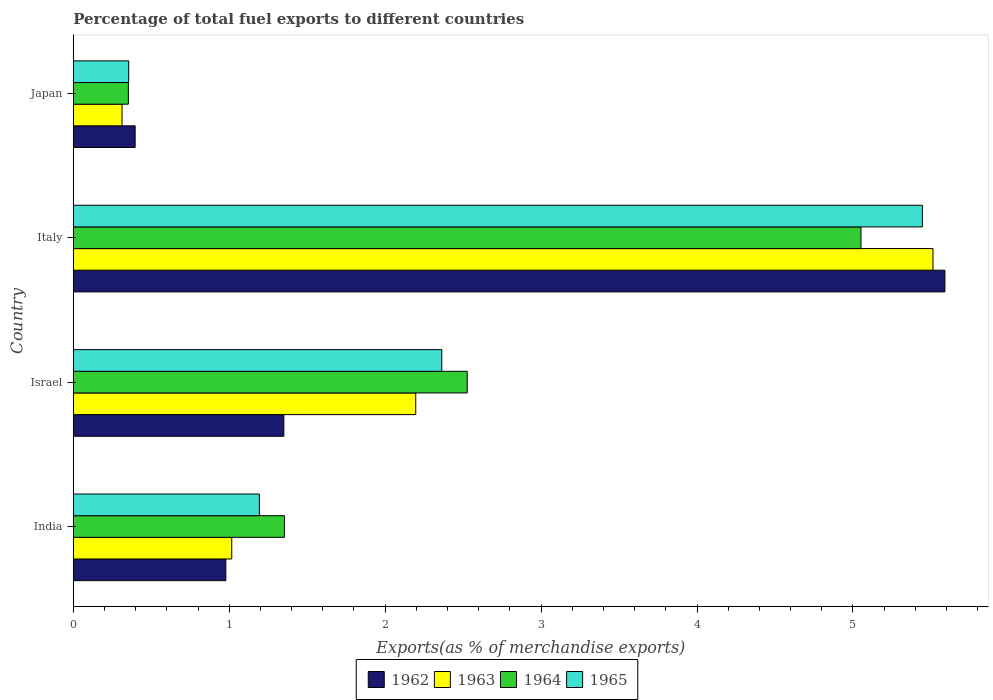How many different coloured bars are there?
Your answer should be compact. 4. What is the label of the 4th group of bars from the top?
Ensure brevity in your answer.  India. In how many cases, is the number of bars for a given country not equal to the number of legend labels?
Give a very brief answer. 0. What is the percentage of exports to different countries in 1965 in Italy?
Ensure brevity in your answer.  5.45. Across all countries, what is the maximum percentage of exports to different countries in 1965?
Provide a short and direct response. 5.45. Across all countries, what is the minimum percentage of exports to different countries in 1965?
Ensure brevity in your answer.  0.36. In which country was the percentage of exports to different countries in 1965 maximum?
Offer a very short reply. Italy. In which country was the percentage of exports to different countries in 1962 minimum?
Make the answer very short. Japan. What is the total percentage of exports to different countries in 1965 in the graph?
Keep it short and to the point. 9.36. What is the difference between the percentage of exports to different countries in 1962 in India and that in Italy?
Provide a short and direct response. -4.61. What is the difference between the percentage of exports to different countries in 1964 in Japan and the percentage of exports to different countries in 1965 in Italy?
Offer a terse response. -5.09. What is the average percentage of exports to different countries in 1965 per country?
Provide a short and direct response. 2.34. What is the difference between the percentage of exports to different countries in 1965 and percentage of exports to different countries in 1964 in Japan?
Give a very brief answer. 0. What is the ratio of the percentage of exports to different countries in 1962 in Israel to that in Italy?
Your answer should be compact. 0.24. Is the difference between the percentage of exports to different countries in 1965 in Israel and Japan greater than the difference between the percentage of exports to different countries in 1964 in Israel and Japan?
Your answer should be compact. No. What is the difference between the highest and the second highest percentage of exports to different countries in 1965?
Your answer should be compact. 3.08. What is the difference between the highest and the lowest percentage of exports to different countries in 1963?
Provide a succinct answer. 5.2. In how many countries, is the percentage of exports to different countries in 1964 greater than the average percentage of exports to different countries in 1964 taken over all countries?
Provide a succinct answer. 2. Is the sum of the percentage of exports to different countries in 1965 in Israel and Japan greater than the maximum percentage of exports to different countries in 1963 across all countries?
Make the answer very short. No. Is it the case that in every country, the sum of the percentage of exports to different countries in 1963 and percentage of exports to different countries in 1962 is greater than the sum of percentage of exports to different countries in 1965 and percentage of exports to different countries in 1964?
Give a very brief answer. No. What does the 2nd bar from the top in Japan represents?
Your answer should be very brief. 1964. What does the 1st bar from the bottom in India represents?
Ensure brevity in your answer.  1962. How many bars are there?
Your answer should be compact. 16. Are all the bars in the graph horizontal?
Make the answer very short. Yes. How many countries are there in the graph?
Keep it short and to the point. 4. What is the difference between two consecutive major ticks on the X-axis?
Your answer should be very brief. 1. Where does the legend appear in the graph?
Ensure brevity in your answer.  Bottom center. How many legend labels are there?
Provide a short and direct response. 4. How are the legend labels stacked?
Offer a terse response. Horizontal. What is the title of the graph?
Provide a short and direct response. Percentage of total fuel exports to different countries. Does "1969" appear as one of the legend labels in the graph?
Keep it short and to the point. No. What is the label or title of the X-axis?
Offer a terse response. Exports(as % of merchandise exports). What is the Exports(as % of merchandise exports) in 1962 in India?
Your answer should be very brief. 0.98. What is the Exports(as % of merchandise exports) in 1963 in India?
Your response must be concise. 1.02. What is the Exports(as % of merchandise exports) in 1964 in India?
Your answer should be very brief. 1.35. What is the Exports(as % of merchandise exports) of 1965 in India?
Provide a short and direct response. 1.19. What is the Exports(as % of merchandise exports) of 1962 in Israel?
Offer a very short reply. 1.35. What is the Exports(as % of merchandise exports) of 1963 in Israel?
Provide a succinct answer. 2.2. What is the Exports(as % of merchandise exports) of 1964 in Israel?
Offer a very short reply. 2.53. What is the Exports(as % of merchandise exports) of 1965 in Israel?
Make the answer very short. 2.36. What is the Exports(as % of merchandise exports) of 1962 in Italy?
Offer a terse response. 5.59. What is the Exports(as % of merchandise exports) in 1963 in Italy?
Give a very brief answer. 5.51. What is the Exports(as % of merchandise exports) of 1964 in Italy?
Your response must be concise. 5.05. What is the Exports(as % of merchandise exports) of 1965 in Italy?
Your answer should be very brief. 5.45. What is the Exports(as % of merchandise exports) of 1962 in Japan?
Make the answer very short. 0.4. What is the Exports(as % of merchandise exports) of 1963 in Japan?
Offer a terse response. 0.31. What is the Exports(as % of merchandise exports) in 1964 in Japan?
Offer a very short reply. 0.35. What is the Exports(as % of merchandise exports) of 1965 in Japan?
Ensure brevity in your answer.  0.36. Across all countries, what is the maximum Exports(as % of merchandise exports) of 1962?
Provide a short and direct response. 5.59. Across all countries, what is the maximum Exports(as % of merchandise exports) in 1963?
Give a very brief answer. 5.51. Across all countries, what is the maximum Exports(as % of merchandise exports) in 1964?
Your response must be concise. 5.05. Across all countries, what is the maximum Exports(as % of merchandise exports) in 1965?
Your answer should be compact. 5.45. Across all countries, what is the minimum Exports(as % of merchandise exports) of 1962?
Provide a short and direct response. 0.4. Across all countries, what is the minimum Exports(as % of merchandise exports) in 1963?
Your answer should be very brief. 0.31. Across all countries, what is the minimum Exports(as % of merchandise exports) of 1964?
Your response must be concise. 0.35. Across all countries, what is the minimum Exports(as % of merchandise exports) in 1965?
Offer a very short reply. 0.36. What is the total Exports(as % of merchandise exports) of 1962 in the graph?
Give a very brief answer. 8.31. What is the total Exports(as % of merchandise exports) in 1963 in the graph?
Provide a succinct answer. 9.04. What is the total Exports(as % of merchandise exports) of 1964 in the graph?
Ensure brevity in your answer.  9.28. What is the total Exports(as % of merchandise exports) in 1965 in the graph?
Offer a very short reply. 9.36. What is the difference between the Exports(as % of merchandise exports) of 1962 in India and that in Israel?
Provide a succinct answer. -0.37. What is the difference between the Exports(as % of merchandise exports) in 1963 in India and that in Israel?
Keep it short and to the point. -1.18. What is the difference between the Exports(as % of merchandise exports) in 1964 in India and that in Israel?
Offer a terse response. -1.17. What is the difference between the Exports(as % of merchandise exports) in 1965 in India and that in Israel?
Your response must be concise. -1.17. What is the difference between the Exports(as % of merchandise exports) of 1962 in India and that in Italy?
Provide a succinct answer. -4.61. What is the difference between the Exports(as % of merchandise exports) of 1963 in India and that in Italy?
Provide a succinct answer. -4.5. What is the difference between the Exports(as % of merchandise exports) of 1964 in India and that in Italy?
Offer a terse response. -3.7. What is the difference between the Exports(as % of merchandise exports) in 1965 in India and that in Italy?
Keep it short and to the point. -4.25. What is the difference between the Exports(as % of merchandise exports) in 1962 in India and that in Japan?
Ensure brevity in your answer.  0.58. What is the difference between the Exports(as % of merchandise exports) of 1963 in India and that in Japan?
Ensure brevity in your answer.  0.7. What is the difference between the Exports(as % of merchandise exports) of 1964 in India and that in Japan?
Keep it short and to the point. 1. What is the difference between the Exports(as % of merchandise exports) in 1965 in India and that in Japan?
Provide a short and direct response. 0.84. What is the difference between the Exports(as % of merchandise exports) in 1962 in Israel and that in Italy?
Keep it short and to the point. -4.24. What is the difference between the Exports(as % of merchandise exports) in 1963 in Israel and that in Italy?
Offer a terse response. -3.32. What is the difference between the Exports(as % of merchandise exports) in 1964 in Israel and that in Italy?
Provide a succinct answer. -2.53. What is the difference between the Exports(as % of merchandise exports) in 1965 in Israel and that in Italy?
Keep it short and to the point. -3.08. What is the difference between the Exports(as % of merchandise exports) in 1962 in Israel and that in Japan?
Make the answer very short. 0.95. What is the difference between the Exports(as % of merchandise exports) in 1963 in Israel and that in Japan?
Provide a short and direct response. 1.88. What is the difference between the Exports(as % of merchandise exports) in 1964 in Israel and that in Japan?
Give a very brief answer. 2.17. What is the difference between the Exports(as % of merchandise exports) in 1965 in Israel and that in Japan?
Ensure brevity in your answer.  2.01. What is the difference between the Exports(as % of merchandise exports) of 1962 in Italy and that in Japan?
Provide a short and direct response. 5.19. What is the difference between the Exports(as % of merchandise exports) in 1963 in Italy and that in Japan?
Your answer should be compact. 5.2. What is the difference between the Exports(as % of merchandise exports) in 1964 in Italy and that in Japan?
Provide a succinct answer. 4.7. What is the difference between the Exports(as % of merchandise exports) in 1965 in Italy and that in Japan?
Your response must be concise. 5.09. What is the difference between the Exports(as % of merchandise exports) in 1962 in India and the Exports(as % of merchandise exports) in 1963 in Israel?
Your answer should be very brief. -1.22. What is the difference between the Exports(as % of merchandise exports) in 1962 in India and the Exports(as % of merchandise exports) in 1964 in Israel?
Give a very brief answer. -1.55. What is the difference between the Exports(as % of merchandise exports) in 1962 in India and the Exports(as % of merchandise exports) in 1965 in Israel?
Give a very brief answer. -1.38. What is the difference between the Exports(as % of merchandise exports) of 1963 in India and the Exports(as % of merchandise exports) of 1964 in Israel?
Provide a succinct answer. -1.51. What is the difference between the Exports(as % of merchandise exports) in 1963 in India and the Exports(as % of merchandise exports) in 1965 in Israel?
Provide a succinct answer. -1.35. What is the difference between the Exports(as % of merchandise exports) of 1964 in India and the Exports(as % of merchandise exports) of 1965 in Israel?
Provide a succinct answer. -1.01. What is the difference between the Exports(as % of merchandise exports) in 1962 in India and the Exports(as % of merchandise exports) in 1963 in Italy?
Ensure brevity in your answer.  -4.54. What is the difference between the Exports(as % of merchandise exports) in 1962 in India and the Exports(as % of merchandise exports) in 1964 in Italy?
Offer a terse response. -4.07. What is the difference between the Exports(as % of merchandise exports) in 1962 in India and the Exports(as % of merchandise exports) in 1965 in Italy?
Offer a terse response. -4.47. What is the difference between the Exports(as % of merchandise exports) in 1963 in India and the Exports(as % of merchandise exports) in 1964 in Italy?
Keep it short and to the point. -4.04. What is the difference between the Exports(as % of merchandise exports) in 1963 in India and the Exports(as % of merchandise exports) in 1965 in Italy?
Your answer should be compact. -4.43. What is the difference between the Exports(as % of merchandise exports) in 1964 in India and the Exports(as % of merchandise exports) in 1965 in Italy?
Ensure brevity in your answer.  -4.09. What is the difference between the Exports(as % of merchandise exports) of 1962 in India and the Exports(as % of merchandise exports) of 1963 in Japan?
Your answer should be very brief. 0.67. What is the difference between the Exports(as % of merchandise exports) of 1962 in India and the Exports(as % of merchandise exports) of 1964 in Japan?
Your answer should be compact. 0.63. What is the difference between the Exports(as % of merchandise exports) in 1962 in India and the Exports(as % of merchandise exports) in 1965 in Japan?
Keep it short and to the point. 0.62. What is the difference between the Exports(as % of merchandise exports) of 1963 in India and the Exports(as % of merchandise exports) of 1964 in Japan?
Offer a terse response. 0.66. What is the difference between the Exports(as % of merchandise exports) of 1963 in India and the Exports(as % of merchandise exports) of 1965 in Japan?
Provide a short and direct response. 0.66. What is the difference between the Exports(as % of merchandise exports) in 1962 in Israel and the Exports(as % of merchandise exports) in 1963 in Italy?
Offer a terse response. -4.16. What is the difference between the Exports(as % of merchandise exports) of 1962 in Israel and the Exports(as % of merchandise exports) of 1964 in Italy?
Your answer should be compact. -3.7. What is the difference between the Exports(as % of merchandise exports) in 1962 in Israel and the Exports(as % of merchandise exports) in 1965 in Italy?
Ensure brevity in your answer.  -4.09. What is the difference between the Exports(as % of merchandise exports) in 1963 in Israel and the Exports(as % of merchandise exports) in 1964 in Italy?
Your response must be concise. -2.86. What is the difference between the Exports(as % of merchandise exports) of 1963 in Israel and the Exports(as % of merchandise exports) of 1965 in Italy?
Make the answer very short. -3.25. What is the difference between the Exports(as % of merchandise exports) in 1964 in Israel and the Exports(as % of merchandise exports) in 1965 in Italy?
Ensure brevity in your answer.  -2.92. What is the difference between the Exports(as % of merchandise exports) in 1962 in Israel and the Exports(as % of merchandise exports) in 1963 in Japan?
Your answer should be very brief. 1.04. What is the difference between the Exports(as % of merchandise exports) of 1962 in Israel and the Exports(as % of merchandise exports) of 1964 in Japan?
Provide a succinct answer. 1. What is the difference between the Exports(as % of merchandise exports) of 1962 in Israel and the Exports(as % of merchandise exports) of 1965 in Japan?
Offer a very short reply. 0.99. What is the difference between the Exports(as % of merchandise exports) in 1963 in Israel and the Exports(as % of merchandise exports) in 1964 in Japan?
Ensure brevity in your answer.  1.84. What is the difference between the Exports(as % of merchandise exports) in 1963 in Israel and the Exports(as % of merchandise exports) in 1965 in Japan?
Your answer should be very brief. 1.84. What is the difference between the Exports(as % of merchandise exports) of 1964 in Israel and the Exports(as % of merchandise exports) of 1965 in Japan?
Keep it short and to the point. 2.17. What is the difference between the Exports(as % of merchandise exports) of 1962 in Italy and the Exports(as % of merchandise exports) of 1963 in Japan?
Your answer should be very brief. 5.28. What is the difference between the Exports(as % of merchandise exports) in 1962 in Italy and the Exports(as % of merchandise exports) in 1964 in Japan?
Keep it short and to the point. 5.24. What is the difference between the Exports(as % of merchandise exports) in 1962 in Italy and the Exports(as % of merchandise exports) in 1965 in Japan?
Provide a short and direct response. 5.23. What is the difference between the Exports(as % of merchandise exports) of 1963 in Italy and the Exports(as % of merchandise exports) of 1964 in Japan?
Give a very brief answer. 5.16. What is the difference between the Exports(as % of merchandise exports) in 1963 in Italy and the Exports(as % of merchandise exports) in 1965 in Japan?
Ensure brevity in your answer.  5.16. What is the difference between the Exports(as % of merchandise exports) in 1964 in Italy and the Exports(as % of merchandise exports) in 1965 in Japan?
Your answer should be compact. 4.7. What is the average Exports(as % of merchandise exports) in 1962 per country?
Ensure brevity in your answer.  2.08. What is the average Exports(as % of merchandise exports) of 1963 per country?
Provide a short and direct response. 2.26. What is the average Exports(as % of merchandise exports) in 1964 per country?
Offer a terse response. 2.32. What is the average Exports(as % of merchandise exports) in 1965 per country?
Your answer should be very brief. 2.34. What is the difference between the Exports(as % of merchandise exports) of 1962 and Exports(as % of merchandise exports) of 1963 in India?
Make the answer very short. -0.04. What is the difference between the Exports(as % of merchandise exports) of 1962 and Exports(as % of merchandise exports) of 1964 in India?
Your response must be concise. -0.38. What is the difference between the Exports(as % of merchandise exports) of 1962 and Exports(as % of merchandise exports) of 1965 in India?
Your answer should be compact. -0.22. What is the difference between the Exports(as % of merchandise exports) of 1963 and Exports(as % of merchandise exports) of 1964 in India?
Provide a short and direct response. -0.34. What is the difference between the Exports(as % of merchandise exports) of 1963 and Exports(as % of merchandise exports) of 1965 in India?
Your answer should be very brief. -0.18. What is the difference between the Exports(as % of merchandise exports) in 1964 and Exports(as % of merchandise exports) in 1965 in India?
Your response must be concise. 0.16. What is the difference between the Exports(as % of merchandise exports) of 1962 and Exports(as % of merchandise exports) of 1963 in Israel?
Your answer should be very brief. -0.85. What is the difference between the Exports(as % of merchandise exports) in 1962 and Exports(as % of merchandise exports) in 1964 in Israel?
Ensure brevity in your answer.  -1.18. What is the difference between the Exports(as % of merchandise exports) in 1962 and Exports(as % of merchandise exports) in 1965 in Israel?
Give a very brief answer. -1.01. What is the difference between the Exports(as % of merchandise exports) of 1963 and Exports(as % of merchandise exports) of 1964 in Israel?
Your answer should be compact. -0.33. What is the difference between the Exports(as % of merchandise exports) of 1963 and Exports(as % of merchandise exports) of 1965 in Israel?
Make the answer very short. -0.17. What is the difference between the Exports(as % of merchandise exports) in 1964 and Exports(as % of merchandise exports) in 1965 in Israel?
Give a very brief answer. 0.16. What is the difference between the Exports(as % of merchandise exports) in 1962 and Exports(as % of merchandise exports) in 1963 in Italy?
Provide a succinct answer. 0.08. What is the difference between the Exports(as % of merchandise exports) in 1962 and Exports(as % of merchandise exports) in 1964 in Italy?
Keep it short and to the point. 0.54. What is the difference between the Exports(as % of merchandise exports) of 1962 and Exports(as % of merchandise exports) of 1965 in Italy?
Your response must be concise. 0.14. What is the difference between the Exports(as % of merchandise exports) of 1963 and Exports(as % of merchandise exports) of 1964 in Italy?
Ensure brevity in your answer.  0.46. What is the difference between the Exports(as % of merchandise exports) of 1963 and Exports(as % of merchandise exports) of 1965 in Italy?
Keep it short and to the point. 0.07. What is the difference between the Exports(as % of merchandise exports) of 1964 and Exports(as % of merchandise exports) of 1965 in Italy?
Provide a short and direct response. -0.39. What is the difference between the Exports(as % of merchandise exports) in 1962 and Exports(as % of merchandise exports) in 1963 in Japan?
Your answer should be compact. 0.08. What is the difference between the Exports(as % of merchandise exports) in 1962 and Exports(as % of merchandise exports) in 1964 in Japan?
Provide a short and direct response. 0.04. What is the difference between the Exports(as % of merchandise exports) in 1962 and Exports(as % of merchandise exports) in 1965 in Japan?
Provide a succinct answer. 0.04. What is the difference between the Exports(as % of merchandise exports) in 1963 and Exports(as % of merchandise exports) in 1964 in Japan?
Provide a succinct answer. -0.04. What is the difference between the Exports(as % of merchandise exports) in 1963 and Exports(as % of merchandise exports) in 1965 in Japan?
Your response must be concise. -0.04. What is the difference between the Exports(as % of merchandise exports) in 1964 and Exports(as % of merchandise exports) in 1965 in Japan?
Your answer should be compact. -0. What is the ratio of the Exports(as % of merchandise exports) in 1962 in India to that in Israel?
Your answer should be very brief. 0.72. What is the ratio of the Exports(as % of merchandise exports) in 1963 in India to that in Israel?
Make the answer very short. 0.46. What is the ratio of the Exports(as % of merchandise exports) of 1964 in India to that in Israel?
Make the answer very short. 0.54. What is the ratio of the Exports(as % of merchandise exports) in 1965 in India to that in Israel?
Offer a terse response. 0.51. What is the ratio of the Exports(as % of merchandise exports) of 1962 in India to that in Italy?
Provide a succinct answer. 0.17. What is the ratio of the Exports(as % of merchandise exports) of 1963 in India to that in Italy?
Give a very brief answer. 0.18. What is the ratio of the Exports(as % of merchandise exports) in 1964 in India to that in Italy?
Keep it short and to the point. 0.27. What is the ratio of the Exports(as % of merchandise exports) in 1965 in India to that in Italy?
Ensure brevity in your answer.  0.22. What is the ratio of the Exports(as % of merchandise exports) in 1962 in India to that in Japan?
Your answer should be very brief. 2.47. What is the ratio of the Exports(as % of merchandise exports) in 1963 in India to that in Japan?
Your response must be concise. 3.25. What is the ratio of the Exports(as % of merchandise exports) of 1964 in India to that in Japan?
Give a very brief answer. 3.83. What is the ratio of the Exports(as % of merchandise exports) of 1965 in India to that in Japan?
Provide a succinct answer. 3.36. What is the ratio of the Exports(as % of merchandise exports) of 1962 in Israel to that in Italy?
Provide a short and direct response. 0.24. What is the ratio of the Exports(as % of merchandise exports) of 1963 in Israel to that in Italy?
Keep it short and to the point. 0.4. What is the ratio of the Exports(as % of merchandise exports) in 1964 in Israel to that in Italy?
Offer a terse response. 0.5. What is the ratio of the Exports(as % of merchandise exports) of 1965 in Israel to that in Italy?
Keep it short and to the point. 0.43. What is the ratio of the Exports(as % of merchandise exports) in 1962 in Israel to that in Japan?
Your answer should be very brief. 3.4. What is the ratio of the Exports(as % of merchandise exports) in 1963 in Israel to that in Japan?
Give a very brief answer. 7.03. What is the ratio of the Exports(as % of merchandise exports) of 1964 in Israel to that in Japan?
Offer a very short reply. 7.16. What is the ratio of the Exports(as % of merchandise exports) in 1965 in Israel to that in Japan?
Give a very brief answer. 6.65. What is the ratio of the Exports(as % of merchandise exports) of 1962 in Italy to that in Japan?
Your answer should be very brief. 14.1. What is the ratio of the Exports(as % of merchandise exports) in 1963 in Italy to that in Japan?
Ensure brevity in your answer.  17.64. What is the ratio of the Exports(as % of merchandise exports) of 1964 in Italy to that in Japan?
Ensure brevity in your answer.  14.31. What is the ratio of the Exports(as % of merchandise exports) in 1965 in Italy to that in Japan?
Offer a terse response. 15.32. What is the difference between the highest and the second highest Exports(as % of merchandise exports) in 1962?
Keep it short and to the point. 4.24. What is the difference between the highest and the second highest Exports(as % of merchandise exports) in 1963?
Ensure brevity in your answer.  3.32. What is the difference between the highest and the second highest Exports(as % of merchandise exports) in 1964?
Ensure brevity in your answer.  2.53. What is the difference between the highest and the second highest Exports(as % of merchandise exports) of 1965?
Make the answer very short. 3.08. What is the difference between the highest and the lowest Exports(as % of merchandise exports) in 1962?
Provide a short and direct response. 5.19. What is the difference between the highest and the lowest Exports(as % of merchandise exports) of 1963?
Your answer should be very brief. 5.2. What is the difference between the highest and the lowest Exports(as % of merchandise exports) of 1964?
Ensure brevity in your answer.  4.7. What is the difference between the highest and the lowest Exports(as % of merchandise exports) in 1965?
Give a very brief answer. 5.09. 